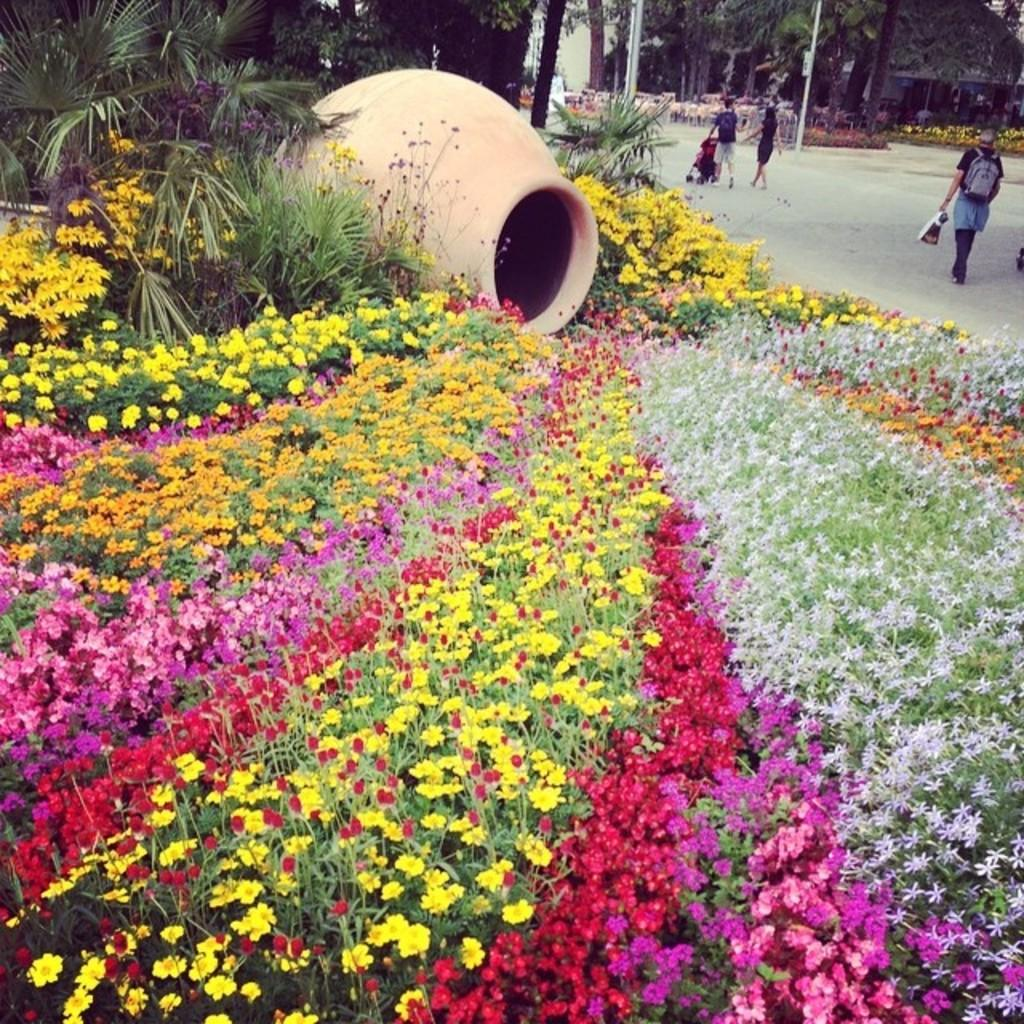What colors are the flowers in the image? The flowers in the image are in pink, yellow, and orange colors. What is the pot used for in the image? The pot is likely used to hold the plants or flowers in the image. What color are the plants and trees in the image? The plants and trees in the image are in green color. What are the people in the image doing? The people in the image are walking. What type of government is depicted in the image? There is no depiction of a government in the image; it features flowers, a pot, plants, trees, and people walking. Can you see any physical contact between the people in the image, such as a kiss? There is no physical contact or kiss depicted between the people in the image; they are simply walking. 